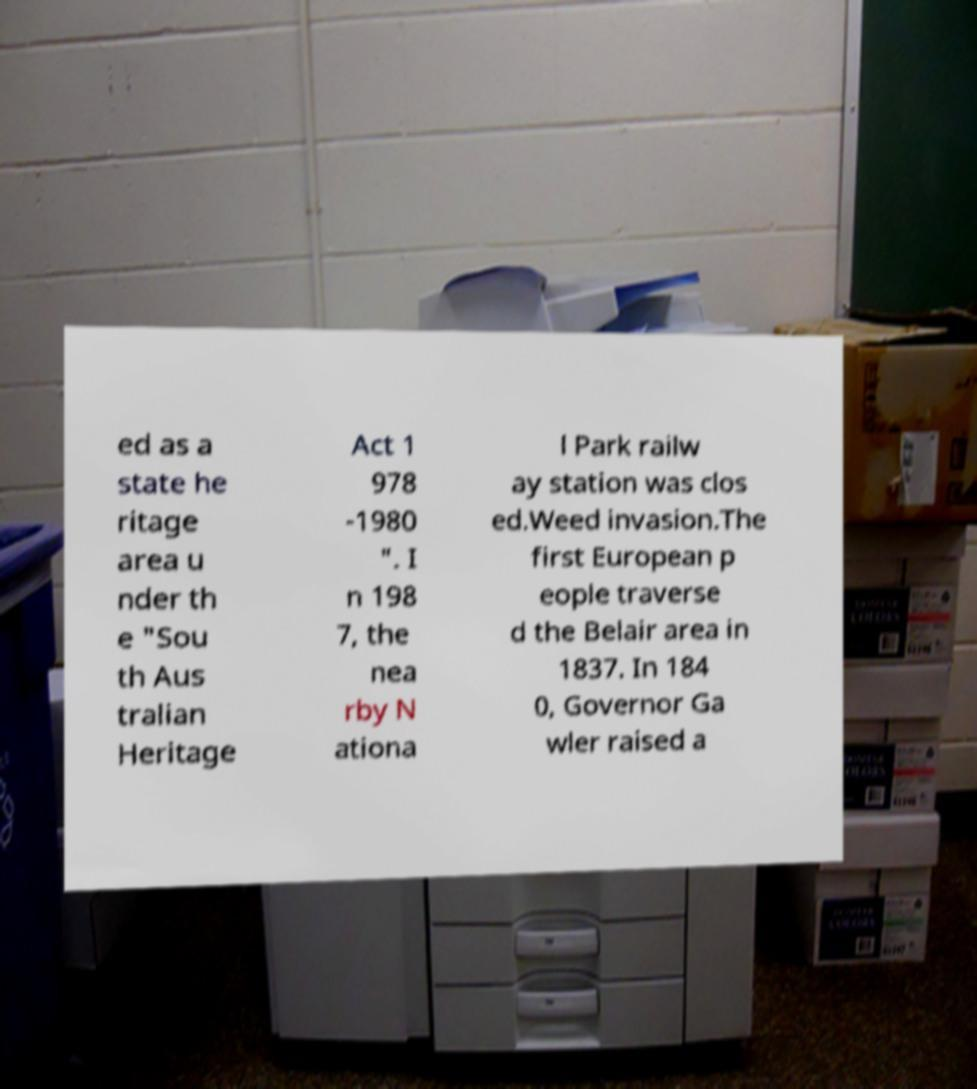Please read and relay the text visible in this image. What does it say? ed as a state he ritage area u nder th e "Sou th Aus tralian Heritage Act 1 978 -1980 ". I n 198 7, the nea rby N ationa l Park railw ay station was clos ed.Weed invasion.The first European p eople traverse d the Belair area in 1837. In 184 0, Governor Ga wler raised a 